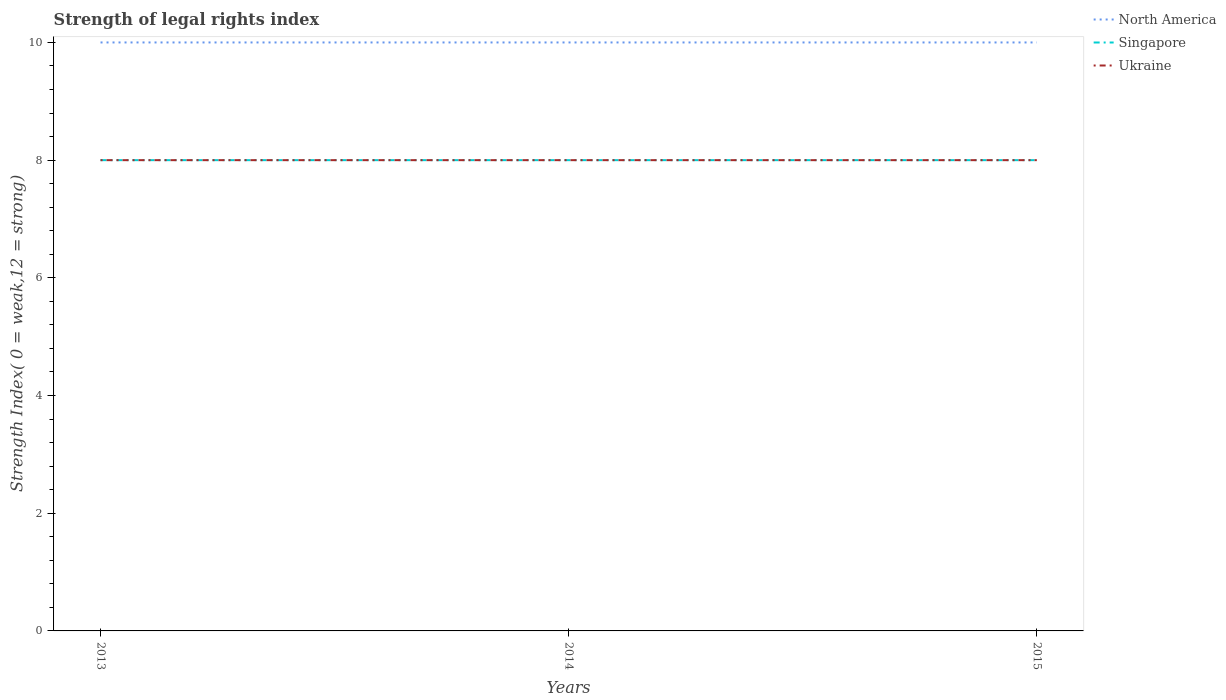Does the line corresponding to North America intersect with the line corresponding to Ukraine?
Your answer should be compact. No. Across all years, what is the maximum strength index in North America?
Your answer should be very brief. 10. In which year was the strength index in Singapore maximum?
Provide a short and direct response. 2013. What is the difference between two consecutive major ticks on the Y-axis?
Offer a very short reply. 2. Does the graph contain grids?
Keep it short and to the point. No. How are the legend labels stacked?
Make the answer very short. Vertical. What is the title of the graph?
Your answer should be compact. Strength of legal rights index. Does "Thailand" appear as one of the legend labels in the graph?
Provide a succinct answer. No. What is the label or title of the Y-axis?
Ensure brevity in your answer.  Strength Index( 0 = weak,12 = strong). What is the Strength Index( 0 = weak,12 = strong) of North America in 2013?
Give a very brief answer. 10. What is the Strength Index( 0 = weak,12 = strong) of North America in 2014?
Provide a succinct answer. 10. What is the Strength Index( 0 = weak,12 = strong) in Ukraine in 2014?
Ensure brevity in your answer.  8. What is the Strength Index( 0 = weak,12 = strong) of Singapore in 2015?
Keep it short and to the point. 8. Across all years, what is the maximum Strength Index( 0 = weak,12 = strong) in Singapore?
Your answer should be compact. 8. Across all years, what is the maximum Strength Index( 0 = weak,12 = strong) of Ukraine?
Your answer should be very brief. 8. Across all years, what is the minimum Strength Index( 0 = weak,12 = strong) of Singapore?
Keep it short and to the point. 8. Across all years, what is the minimum Strength Index( 0 = weak,12 = strong) of Ukraine?
Give a very brief answer. 8. What is the total Strength Index( 0 = weak,12 = strong) of North America in the graph?
Make the answer very short. 30. What is the difference between the Strength Index( 0 = weak,12 = strong) in Singapore in 2013 and that in 2014?
Provide a short and direct response. 0. What is the difference between the Strength Index( 0 = weak,12 = strong) in Ukraine in 2013 and that in 2014?
Ensure brevity in your answer.  0. What is the difference between the Strength Index( 0 = weak,12 = strong) of Singapore in 2013 and that in 2015?
Give a very brief answer. 0. What is the difference between the Strength Index( 0 = weak,12 = strong) of North America in 2014 and that in 2015?
Offer a very short reply. 0. What is the difference between the Strength Index( 0 = weak,12 = strong) of Singapore in 2014 and that in 2015?
Make the answer very short. 0. What is the difference between the Strength Index( 0 = weak,12 = strong) of Ukraine in 2014 and that in 2015?
Your answer should be very brief. 0. What is the difference between the Strength Index( 0 = weak,12 = strong) of North America in 2013 and the Strength Index( 0 = weak,12 = strong) of Singapore in 2015?
Offer a very short reply. 2. What is the difference between the Strength Index( 0 = weak,12 = strong) of North America in 2013 and the Strength Index( 0 = weak,12 = strong) of Ukraine in 2015?
Offer a terse response. 2. What is the difference between the Strength Index( 0 = weak,12 = strong) in Singapore in 2013 and the Strength Index( 0 = weak,12 = strong) in Ukraine in 2015?
Make the answer very short. 0. What is the difference between the Strength Index( 0 = weak,12 = strong) in North America in 2014 and the Strength Index( 0 = weak,12 = strong) in Singapore in 2015?
Your answer should be compact. 2. What is the average Strength Index( 0 = weak,12 = strong) of North America per year?
Offer a very short reply. 10. What is the average Strength Index( 0 = weak,12 = strong) in Singapore per year?
Make the answer very short. 8. In the year 2013, what is the difference between the Strength Index( 0 = weak,12 = strong) in North America and Strength Index( 0 = weak,12 = strong) in Ukraine?
Give a very brief answer. 2. In the year 2015, what is the difference between the Strength Index( 0 = weak,12 = strong) of Singapore and Strength Index( 0 = weak,12 = strong) of Ukraine?
Provide a short and direct response. 0. What is the ratio of the Strength Index( 0 = weak,12 = strong) of Singapore in 2013 to that in 2014?
Offer a terse response. 1. What is the ratio of the Strength Index( 0 = weak,12 = strong) of Singapore in 2013 to that in 2015?
Provide a short and direct response. 1. What is the ratio of the Strength Index( 0 = weak,12 = strong) in North America in 2014 to that in 2015?
Provide a succinct answer. 1. What is the ratio of the Strength Index( 0 = weak,12 = strong) of Ukraine in 2014 to that in 2015?
Your answer should be compact. 1. What is the difference between the highest and the second highest Strength Index( 0 = weak,12 = strong) in North America?
Your response must be concise. 0. What is the difference between the highest and the lowest Strength Index( 0 = weak,12 = strong) in North America?
Offer a terse response. 0. 